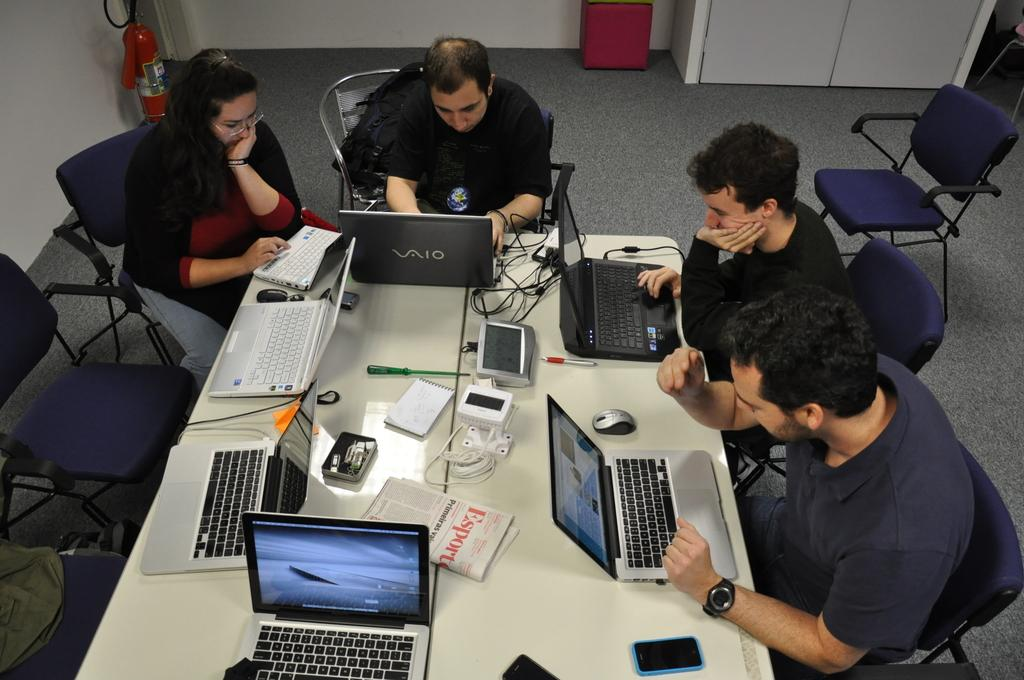<image>
Summarize the visual content of the image. Workers use Vaio technology to complete their work. 